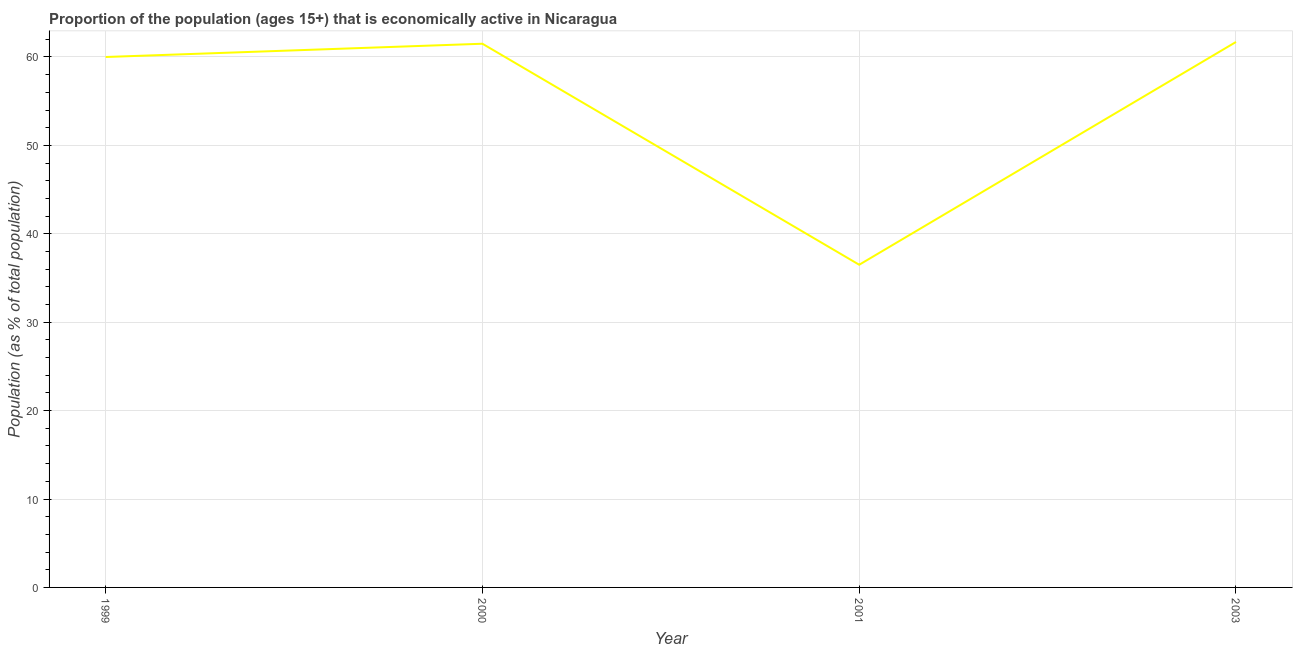What is the percentage of economically active population in 2003?
Make the answer very short. 61.7. Across all years, what is the maximum percentage of economically active population?
Make the answer very short. 61.7. Across all years, what is the minimum percentage of economically active population?
Keep it short and to the point. 36.5. In which year was the percentage of economically active population maximum?
Make the answer very short. 2003. What is the sum of the percentage of economically active population?
Make the answer very short. 219.7. What is the difference between the percentage of economically active population in 1999 and 2003?
Offer a terse response. -1.7. What is the average percentage of economically active population per year?
Offer a very short reply. 54.93. What is the median percentage of economically active population?
Your answer should be compact. 60.75. What is the ratio of the percentage of economically active population in 1999 to that in 2001?
Your answer should be very brief. 1.64. Is the percentage of economically active population in 2001 less than that in 2003?
Provide a succinct answer. Yes. Is the difference between the percentage of economically active population in 2000 and 2001 greater than the difference between any two years?
Give a very brief answer. No. What is the difference between the highest and the second highest percentage of economically active population?
Your response must be concise. 0.2. Is the sum of the percentage of economically active population in 1999 and 2000 greater than the maximum percentage of economically active population across all years?
Keep it short and to the point. Yes. What is the difference between the highest and the lowest percentage of economically active population?
Provide a succinct answer. 25.2. In how many years, is the percentage of economically active population greater than the average percentage of economically active population taken over all years?
Ensure brevity in your answer.  3. How many lines are there?
Keep it short and to the point. 1. Are the values on the major ticks of Y-axis written in scientific E-notation?
Your answer should be compact. No. Does the graph contain grids?
Make the answer very short. Yes. What is the title of the graph?
Your answer should be very brief. Proportion of the population (ages 15+) that is economically active in Nicaragua. What is the label or title of the Y-axis?
Offer a very short reply. Population (as % of total population). What is the Population (as % of total population) of 2000?
Keep it short and to the point. 61.5. What is the Population (as % of total population) of 2001?
Your response must be concise. 36.5. What is the Population (as % of total population) in 2003?
Your answer should be compact. 61.7. What is the difference between the Population (as % of total population) in 1999 and 2000?
Make the answer very short. -1.5. What is the difference between the Population (as % of total population) in 1999 and 2003?
Keep it short and to the point. -1.7. What is the difference between the Population (as % of total population) in 2000 and 2001?
Provide a short and direct response. 25. What is the difference between the Population (as % of total population) in 2000 and 2003?
Make the answer very short. -0.2. What is the difference between the Population (as % of total population) in 2001 and 2003?
Your answer should be compact. -25.2. What is the ratio of the Population (as % of total population) in 1999 to that in 2001?
Your answer should be compact. 1.64. What is the ratio of the Population (as % of total population) in 1999 to that in 2003?
Provide a succinct answer. 0.97. What is the ratio of the Population (as % of total population) in 2000 to that in 2001?
Your response must be concise. 1.69. What is the ratio of the Population (as % of total population) in 2001 to that in 2003?
Provide a short and direct response. 0.59. 